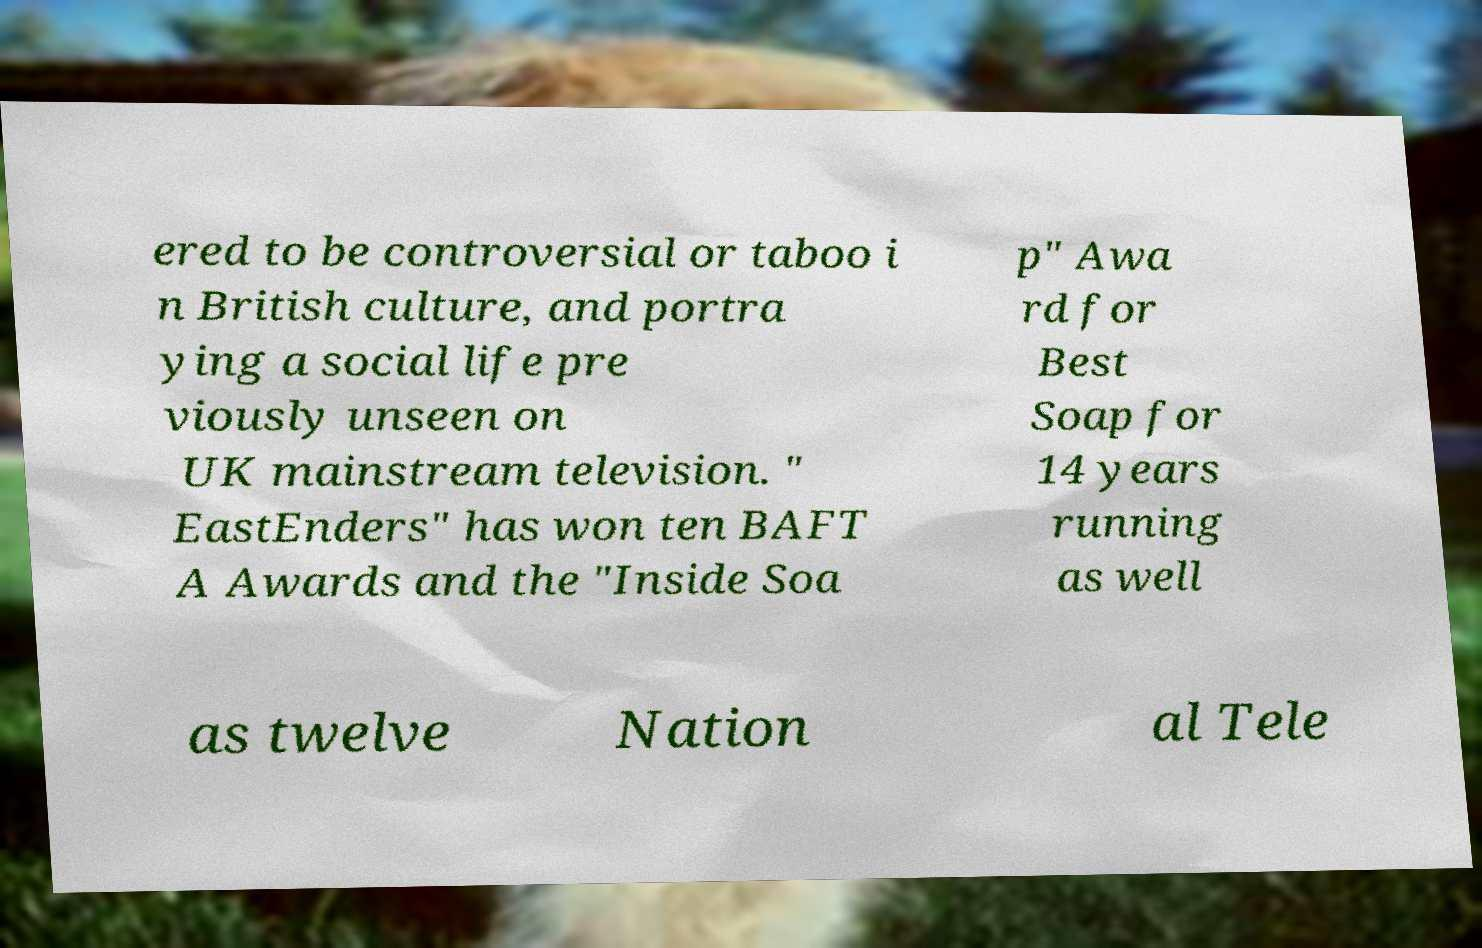Can you accurately transcribe the text from the provided image for me? ered to be controversial or taboo i n British culture, and portra ying a social life pre viously unseen on UK mainstream television. " EastEnders" has won ten BAFT A Awards and the "Inside Soa p" Awa rd for Best Soap for 14 years running as well as twelve Nation al Tele 